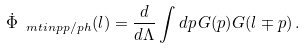Convert formula to latex. <formula><loc_0><loc_0><loc_500><loc_500>\dot { \Phi } _ { \ m t i n { p p / p h } } ( l ) = \frac { d } { d \Lambda } \int d p \, G ( p ) G ( l \mp p ) \, .</formula> 